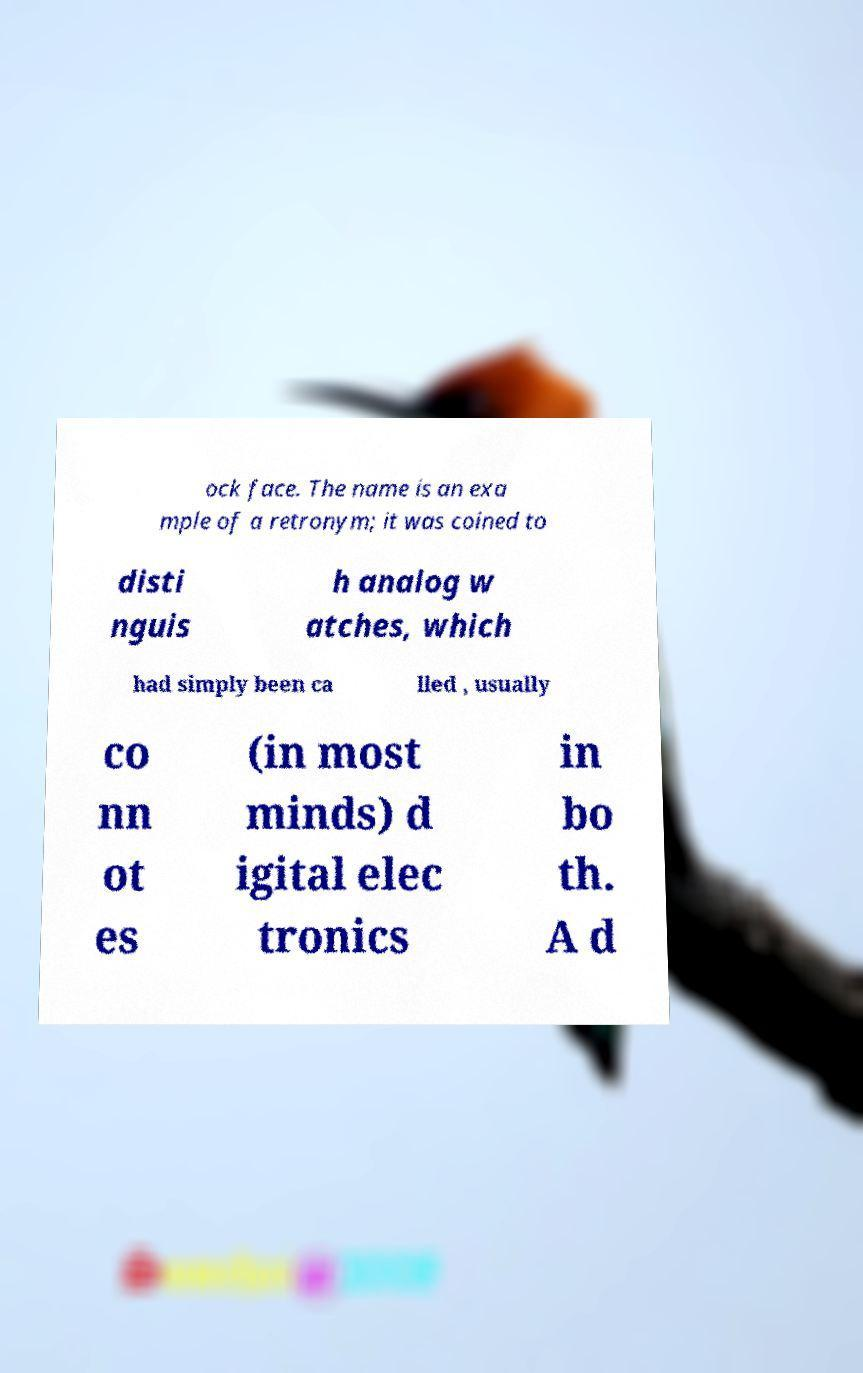Could you assist in decoding the text presented in this image and type it out clearly? ock face. The name is an exa mple of a retronym; it was coined to disti nguis h analog w atches, which had simply been ca lled , usually co nn ot es (in most minds) d igital elec tronics in bo th. A d 